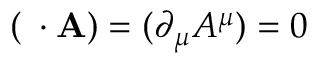<formula> <loc_0><loc_0><loc_500><loc_500>( \partial \cdot A ) = ( \partial _ { \mu } A ^ { \mu } ) = 0</formula> 